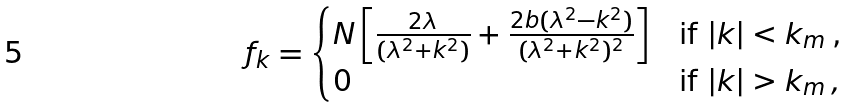<formula> <loc_0><loc_0><loc_500><loc_500>f _ { k } = \begin{cases} N \left [ \frac { 2 \lambda } { ( \lambda ^ { 2 } + k ^ { 2 } ) } + \frac { 2 b ( \lambda ^ { 2 } - k ^ { 2 } ) } { ( \lambda ^ { 2 } + k ^ { 2 } ) ^ { 2 } } \right ] & \text {if $|k|<k_{m}$\,,} \\ 0 & \text {if $|k|>k_{m}$} \, , \end{cases}</formula> 